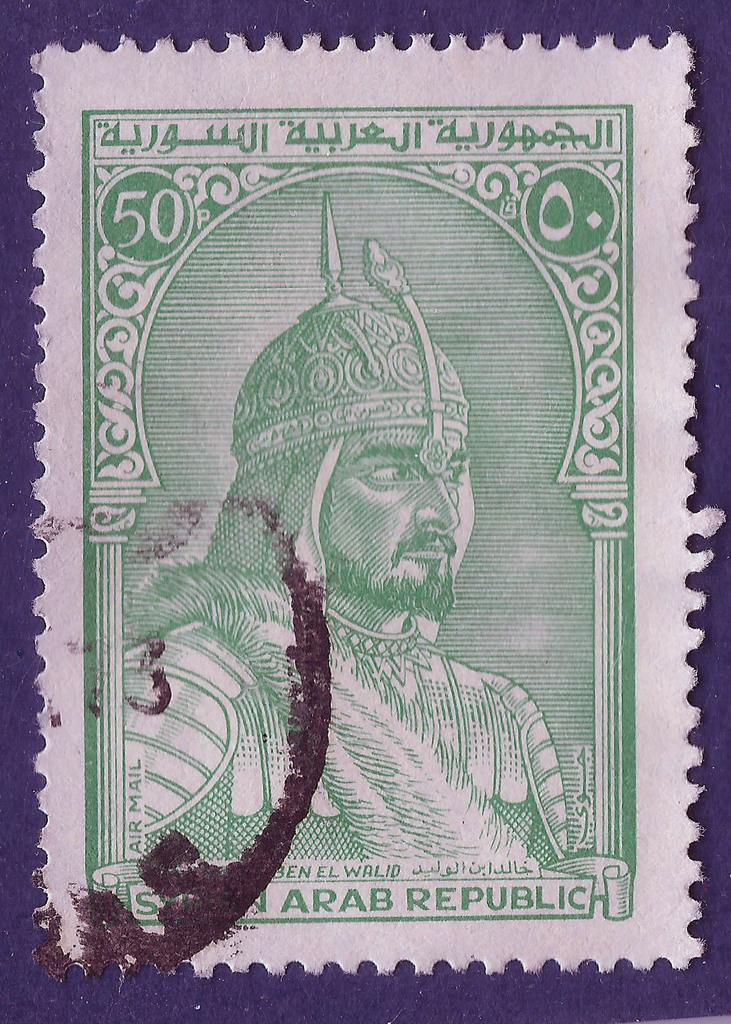Could you give a brief overview of what you see in this image? In this picture we can see a postage stamp of a person and on the postage stamp it is written something. 